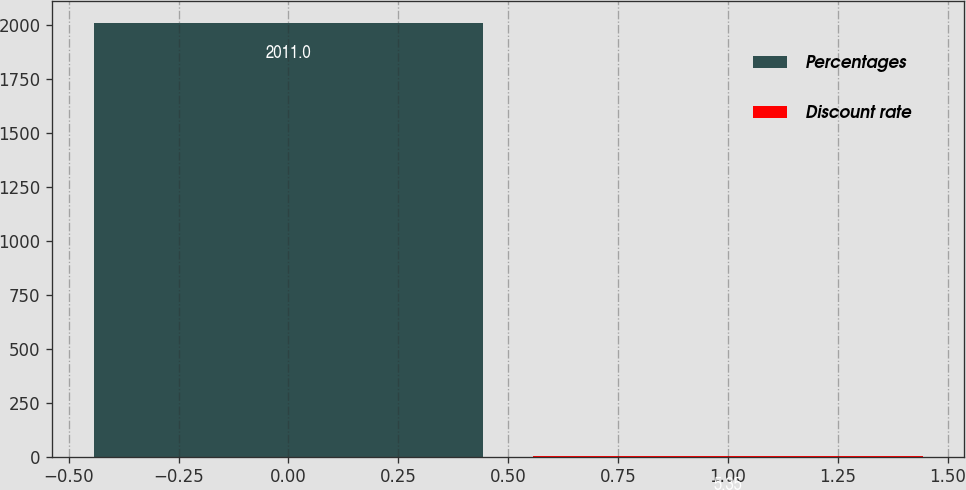Convert chart. <chart><loc_0><loc_0><loc_500><loc_500><bar_chart><fcel>Percentages<fcel>Discount rate<nl><fcel>2011<fcel>5.35<nl></chart> 